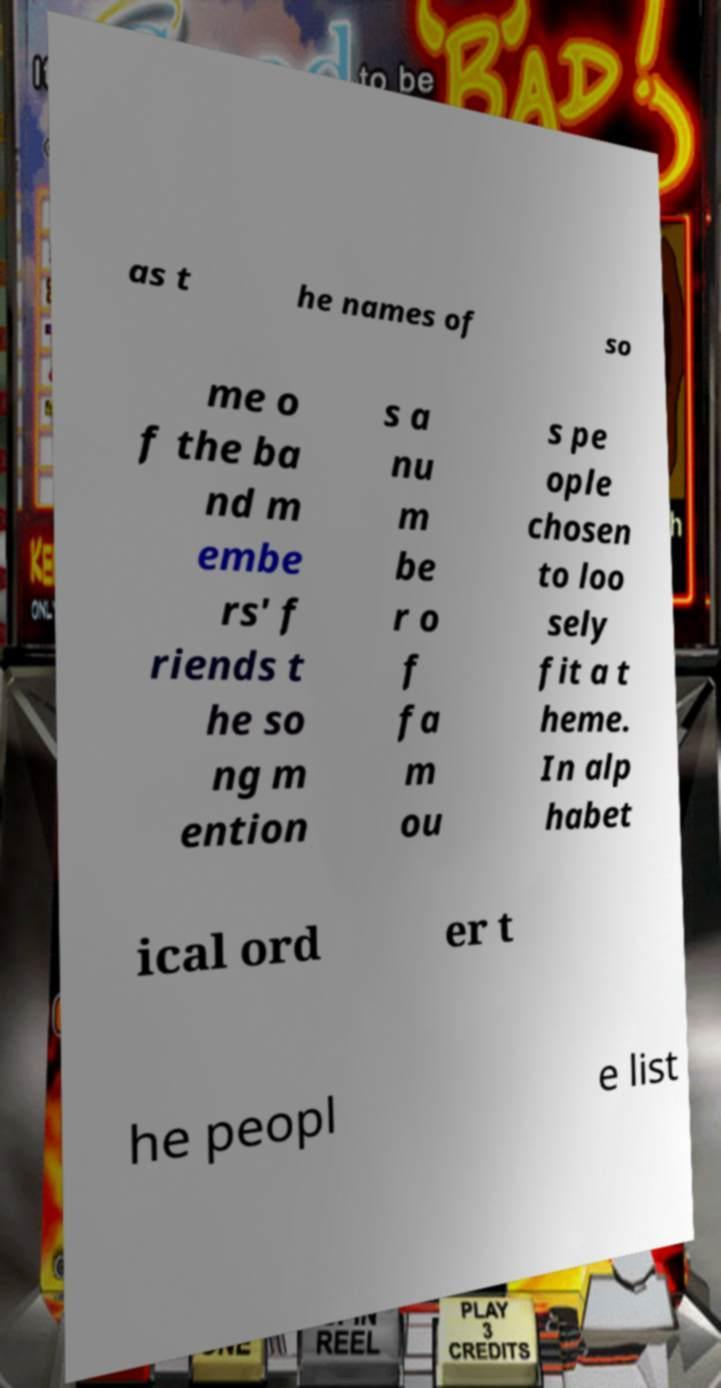Can you accurately transcribe the text from the provided image for me? as t he names of so me o f the ba nd m embe rs' f riends t he so ng m ention s a nu m be r o f fa m ou s pe ople chosen to loo sely fit a t heme. In alp habet ical ord er t he peopl e list 